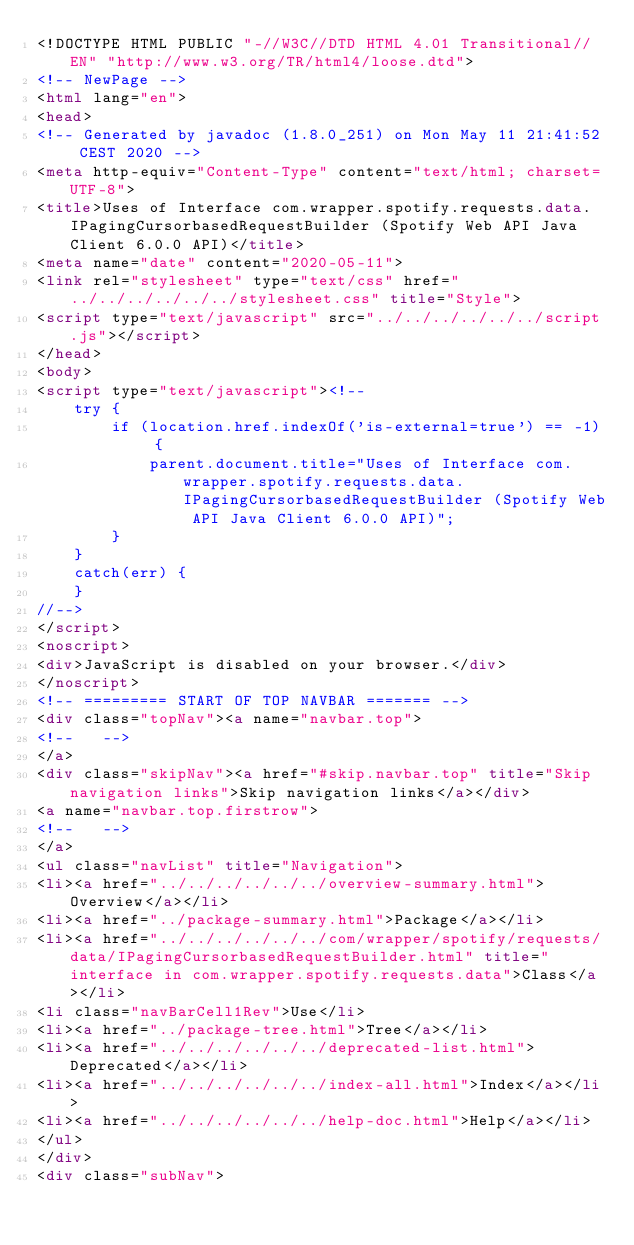Convert code to text. <code><loc_0><loc_0><loc_500><loc_500><_HTML_><!DOCTYPE HTML PUBLIC "-//W3C//DTD HTML 4.01 Transitional//EN" "http://www.w3.org/TR/html4/loose.dtd">
<!-- NewPage -->
<html lang="en">
<head>
<!-- Generated by javadoc (1.8.0_251) on Mon May 11 21:41:52 CEST 2020 -->
<meta http-equiv="Content-Type" content="text/html; charset=UTF-8">
<title>Uses of Interface com.wrapper.spotify.requests.data.IPagingCursorbasedRequestBuilder (Spotify Web API Java Client 6.0.0 API)</title>
<meta name="date" content="2020-05-11">
<link rel="stylesheet" type="text/css" href="../../../../../../stylesheet.css" title="Style">
<script type="text/javascript" src="../../../../../../script.js"></script>
</head>
<body>
<script type="text/javascript"><!--
    try {
        if (location.href.indexOf('is-external=true') == -1) {
            parent.document.title="Uses of Interface com.wrapper.spotify.requests.data.IPagingCursorbasedRequestBuilder (Spotify Web API Java Client 6.0.0 API)";
        }
    }
    catch(err) {
    }
//-->
</script>
<noscript>
<div>JavaScript is disabled on your browser.</div>
</noscript>
<!-- ========= START OF TOP NAVBAR ======= -->
<div class="topNav"><a name="navbar.top">
<!--   -->
</a>
<div class="skipNav"><a href="#skip.navbar.top" title="Skip navigation links">Skip navigation links</a></div>
<a name="navbar.top.firstrow">
<!--   -->
</a>
<ul class="navList" title="Navigation">
<li><a href="../../../../../../overview-summary.html">Overview</a></li>
<li><a href="../package-summary.html">Package</a></li>
<li><a href="../../../../../../com/wrapper/spotify/requests/data/IPagingCursorbasedRequestBuilder.html" title="interface in com.wrapper.spotify.requests.data">Class</a></li>
<li class="navBarCell1Rev">Use</li>
<li><a href="../package-tree.html">Tree</a></li>
<li><a href="../../../../../../deprecated-list.html">Deprecated</a></li>
<li><a href="../../../../../../index-all.html">Index</a></li>
<li><a href="../../../../../../help-doc.html">Help</a></li>
</ul>
</div>
<div class="subNav"></code> 